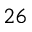<formula> <loc_0><loc_0><loc_500><loc_500>^ { 2 6 }</formula> 